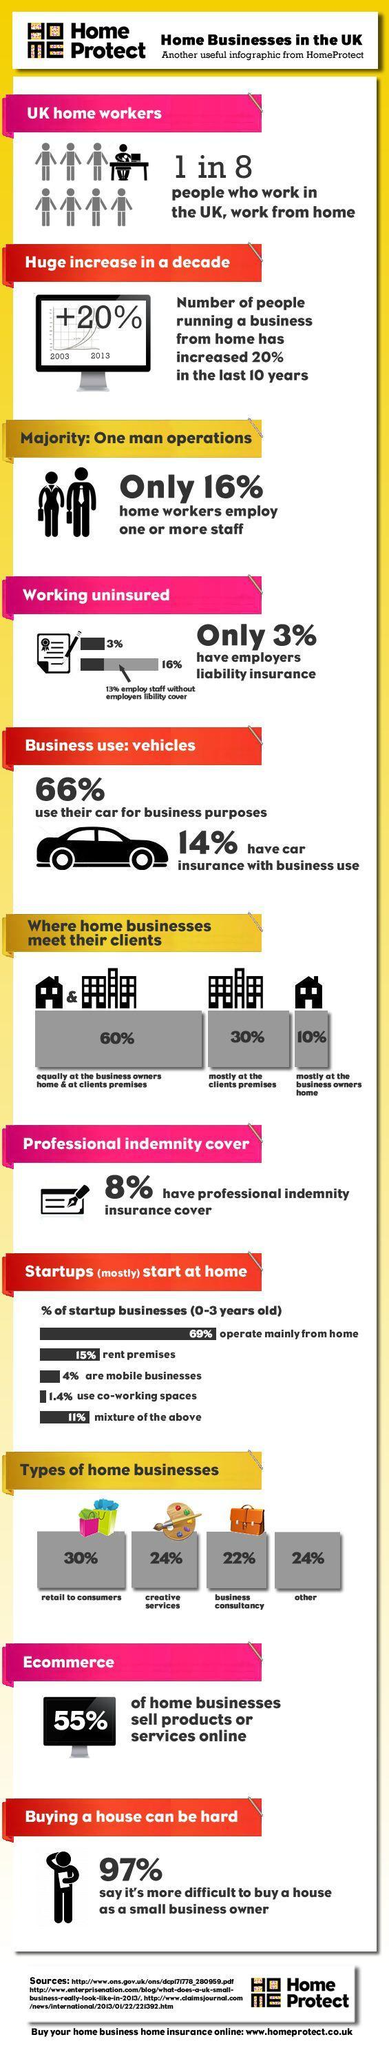What percentage of home businesses in UK are business consultancy?
Answer the question with a short phrase. 22% What percent of startup businesses in UK use co-working spaces? 1.4% What percentage of home businesses in UK do not sell online products or services? 45% What percent of startup businesses in UK operate mainly from home? 69% What percent of home businesses in UK meet their clients mostly at the business owners home? 10% What percentage of home businesses in UK are creative services? 24% What percent of home businesses in UK meet their clients mostly at the clients premises? 30% 